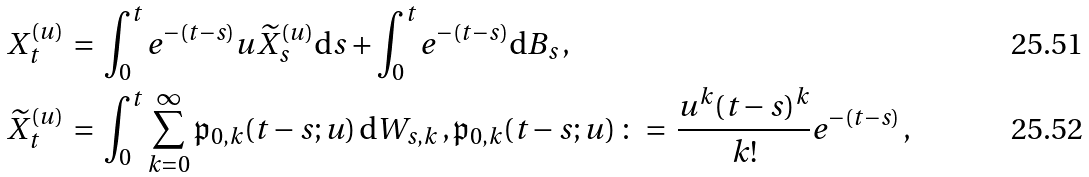Convert formula to latex. <formula><loc_0><loc_0><loc_500><loc_500>X _ { t } ^ { ( u ) } \, & = \, \int ^ { t } _ { 0 } e ^ { - ( t - s ) } u \widetilde { X } ^ { ( u ) } _ { s } { \mathrm d } s + \int ^ { t } _ { 0 } e ^ { - ( t - s ) } { \mathrm d } B _ { s } \, , \\ \widetilde { X } _ { t } ^ { ( u ) } \, & = \, \int ^ { t } _ { 0 } \sum _ { k = 0 } ^ { \infty } \mathfrak p _ { 0 , k } ( t - s ; u ) \, { \mathrm d } W _ { s , k } \, , \mathfrak p _ { 0 , k } ( t - s ; u ) \, \colon = \, \frac { u ^ { k } ( t - s ) ^ { k } } { k ! } e ^ { - ( t - s ) } \, ,</formula> 